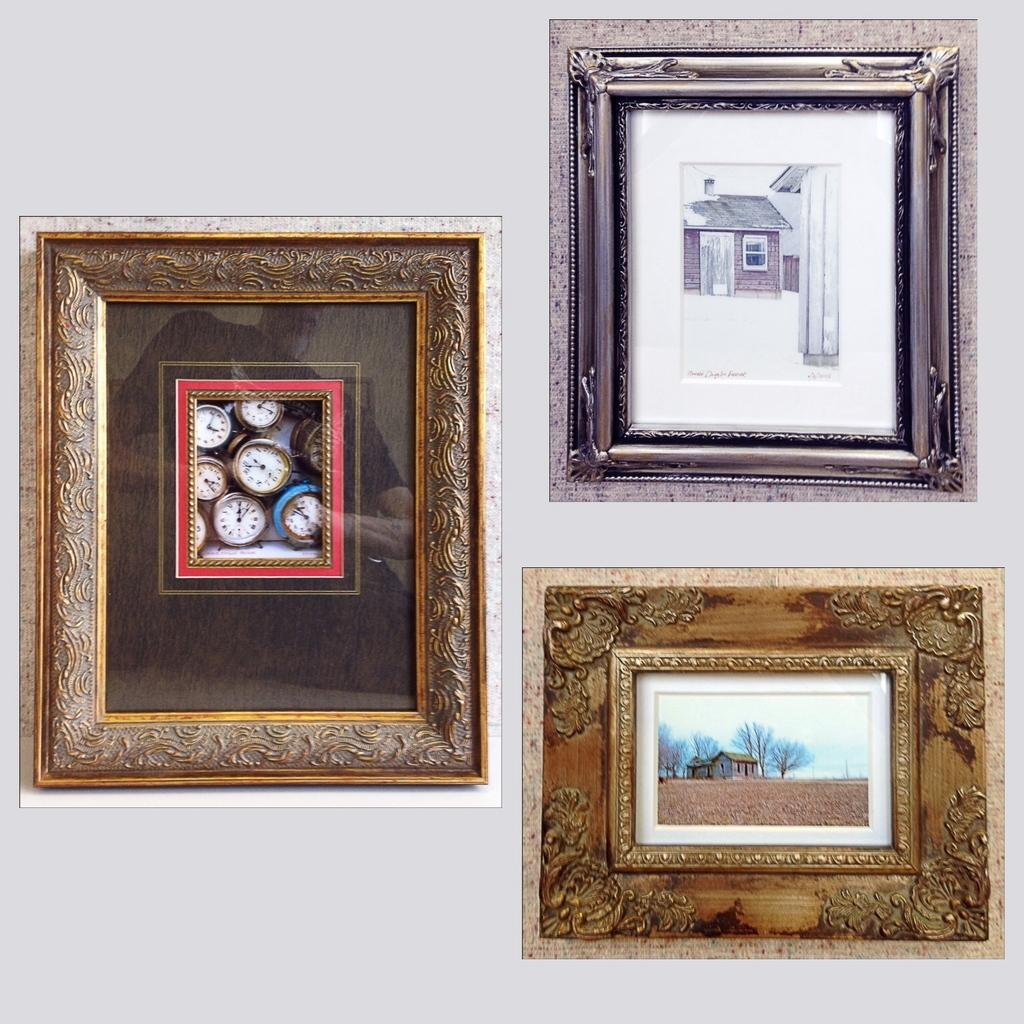How many photo frames are visible in the image? There are three types of photo frames in the image. Where are the photo frames located in the image? The photo frames are attached to the wall. What is the color of the wall in the image? The wall is white in color. What type of acoustics can be heard from the photo frames in the image? There is no sound or acoustics associated with the photo frames in the image. How much payment is required to purchase the photo frames in the image? The image does not provide information about the cost or payment for the photo frames. 